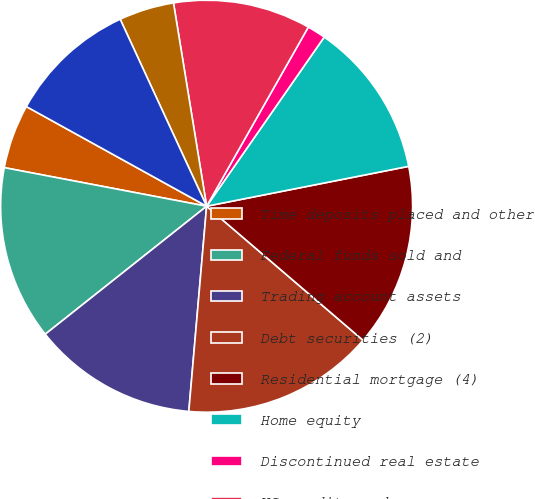<chart> <loc_0><loc_0><loc_500><loc_500><pie_chart><fcel>Time deposits placed and other<fcel>Federal funds sold and<fcel>Trading account assets<fcel>Debt securities (2)<fcel>Residential mortgage (4)<fcel>Home equity<fcel>Discontinued real estate<fcel>US credit card<fcel>Non-US credit card<fcel>Direct/Indirect consumer (5)<nl><fcel>5.04%<fcel>13.67%<fcel>12.95%<fcel>15.1%<fcel>14.38%<fcel>12.23%<fcel>1.45%<fcel>10.79%<fcel>4.32%<fcel>10.07%<nl></chart> 